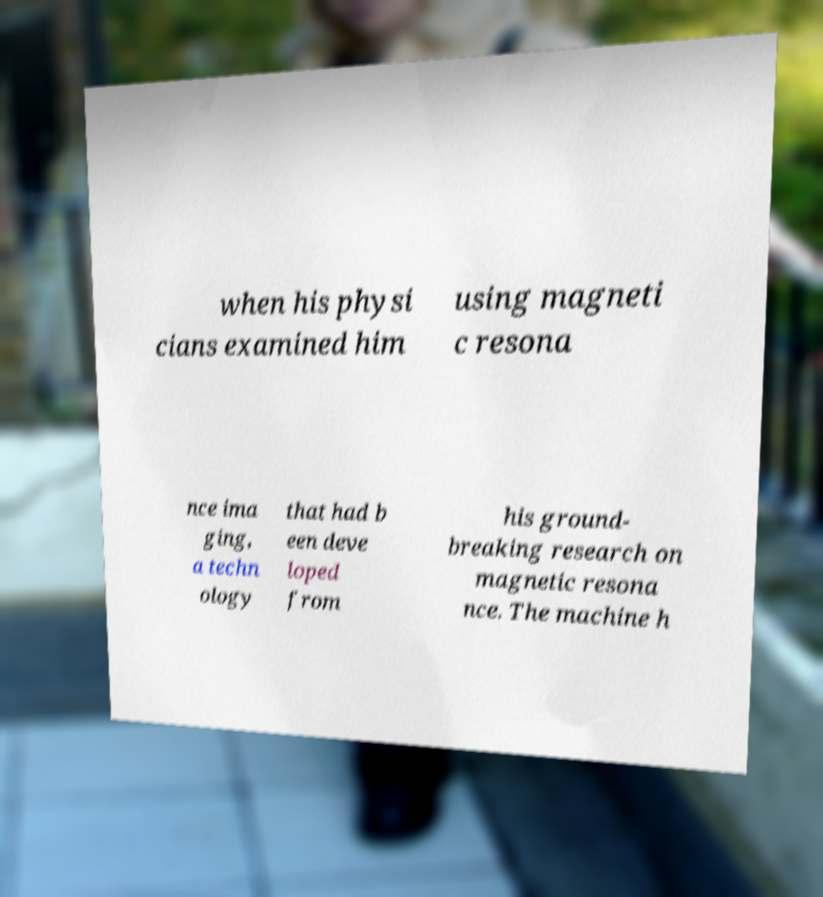There's text embedded in this image that I need extracted. Can you transcribe it verbatim? when his physi cians examined him using magneti c resona nce ima ging, a techn ology that had b een deve loped from his ground- breaking research on magnetic resona nce. The machine h 